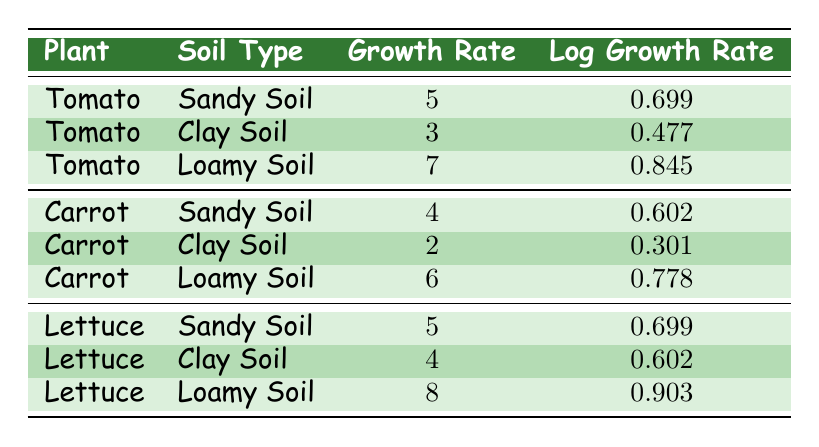What is the growth rate of tomatoes in loamy soil? The table indicates that the growth rate for tomatoes in loamy soil is listed in the row corresponding to "Tomato" and "Loamy Soil," which shows a growth rate of 7 cm per week.
Answer: 7 cm/week Which soil type shows the highest growth rate for carrots? By looking at the rows for "Carrot," we find that the growth rates are 4 cm/week for Sandy Soil, 2 cm/week for Clay Soil, and 6 cm/week for Loamy Soil. The highest growth rate is 6 cm/week in Loamy Soil.
Answer: Loamy Soil What is the average growth rate for lettuce across all soil types? The growth rates for lettuce are 5 cm/week (Sandy Soil), 4 cm/week (Clay Soil), and 8 cm/week (Loamy Soil). First, we sum these values: 5 + 4 + 8 = 17 cm. Since there are 3 soil types, we divide by 3: 17 / 3 = approximately 5.67 cm/week.
Answer: 5.67 cm/week Is the growth rate of carrots in sandy soil greater than that in clay soil? According to the table, the growth rate for carrots in Sandy Soil is 4 cm/week, while in Clay Soil it is 2 cm/week. Since 4 cm/week is greater than 2 cm/week, the statement is true.
Answer: Yes Which plant has the highest logarithmic growth rate in clay soil? The table shows two plants in Clay Soil: Tomatoes with a log growth rate of 0.477 and Carrots with a log growth rate of 0.301. Comparing these, 0.477 is greater than 0.301, so the tomato has the highest logarithmic growth rate in clay soil.
Answer: Tomato 